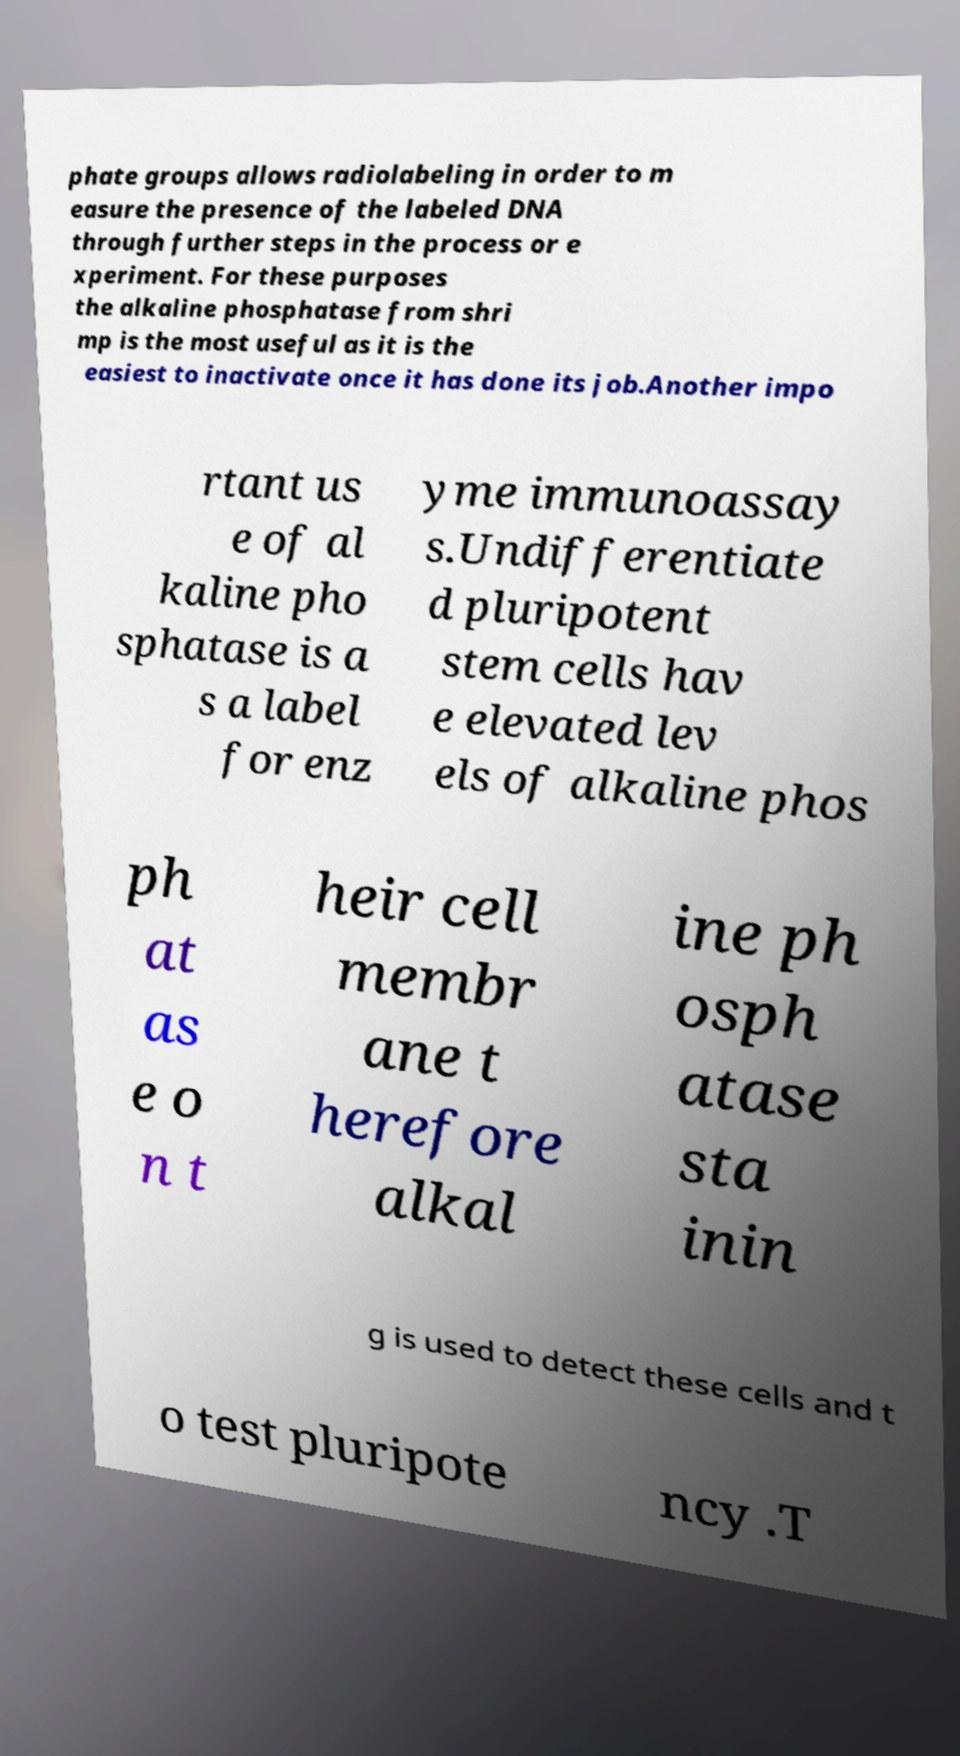Please identify and transcribe the text found in this image. phate groups allows radiolabeling in order to m easure the presence of the labeled DNA through further steps in the process or e xperiment. For these purposes the alkaline phosphatase from shri mp is the most useful as it is the easiest to inactivate once it has done its job.Another impo rtant us e of al kaline pho sphatase is a s a label for enz yme immunoassay s.Undifferentiate d pluripotent stem cells hav e elevated lev els of alkaline phos ph at as e o n t heir cell membr ane t herefore alkal ine ph osph atase sta inin g is used to detect these cells and t o test pluripote ncy .T 